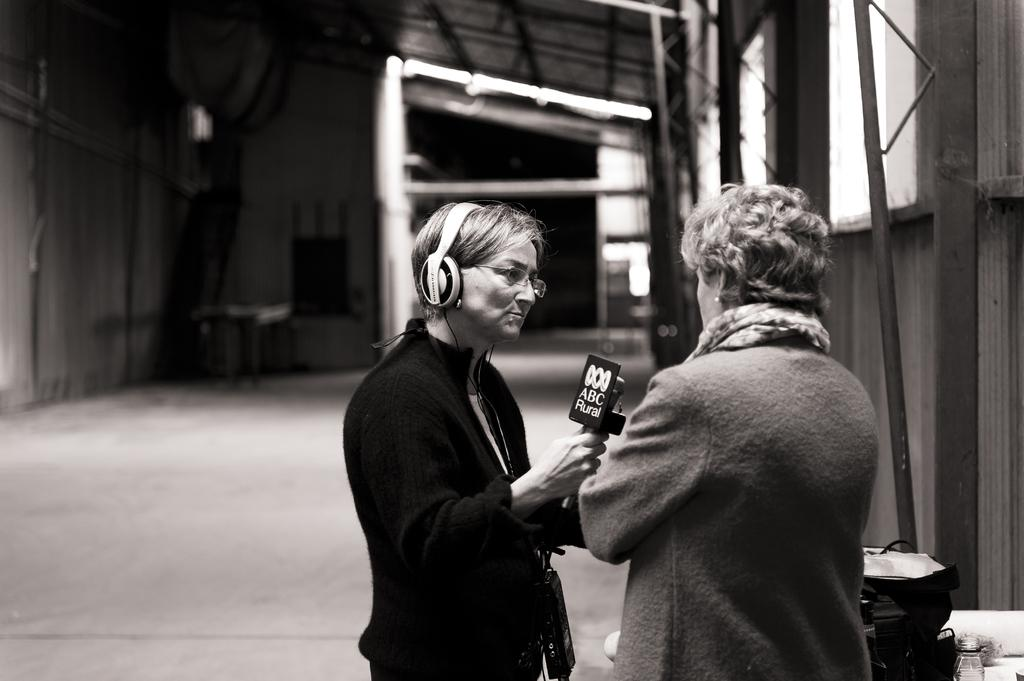How many people are in the image? There are two persons in the image. What are the persons doing in the image? The persons are standing and holding microphones. What accessories are the persons wearing in the image? The persons are wearing headsets and glasses. What is on the floor in the image? There is a bag on the floor. What can be seen in the background of the image? There is a wall and windows in the background. What type of instrument is being played by the persons in the image? There is no instrument visible in the image; the persons are holding microphones and wearing headsets. Can you see any oranges in the image? There are no oranges present in the image. 